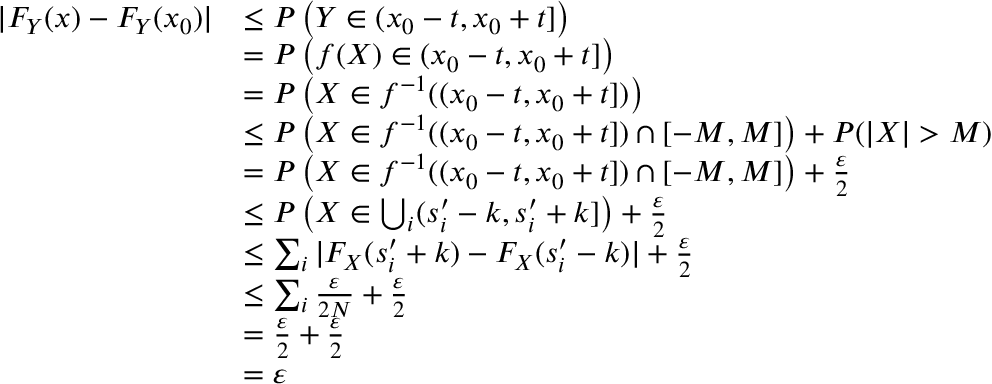<formula> <loc_0><loc_0><loc_500><loc_500>\begin{array} { r l } { | F _ { Y } ( x ) - F _ { Y } ( x _ { 0 } ) | } & { \leq P \left ( Y \in ( x _ { 0 } - t , x _ { 0 } + t ] \right ) } \\ & { = P \left ( f ( X ) \in ( x _ { 0 } - t , x _ { 0 } + t ] \right ) } \\ & { = P \left ( X \in f ^ { - 1 } ( ( x _ { 0 } - t , x _ { 0 } + t ] ) \right ) } \\ & { \leq P \left ( X \in f ^ { - 1 } ( ( x _ { 0 } - t , x _ { 0 } + t ] ) \cap [ - M , M ] \right ) + P ( | X | > M ) } \\ & { = P \left ( X \in f ^ { - 1 } ( ( x _ { 0 } - t , x _ { 0 } + t ] ) \cap [ - M , M ] \right ) + \frac { \varepsilon } { 2 } } \\ & { \leq P \left ( X \in \bigcup _ { i } ( s _ { i } ^ { \prime } - k , s _ { i } ^ { \prime } + k ] \right ) + \frac { \varepsilon } { 2 } } \\ & { \leq \sum _ { i } | F _ { X } ( s _ { i } ^ { \prime } + k ) - F _ { X } ( s _ { i } ^ { \prime } - k ) | + \frac { \varepsilon } { 2 } } \\ & { \leq \sum _ { i } \frac { \varepsilon } { 2 N } + \frac { \varepsilon } { 2 } } \\ & { = \frac { \varepsilon } { 2 } + \frac { \varepsilon } { 2 } } \\ & { = \varepsilon } \end{array}</formula> 